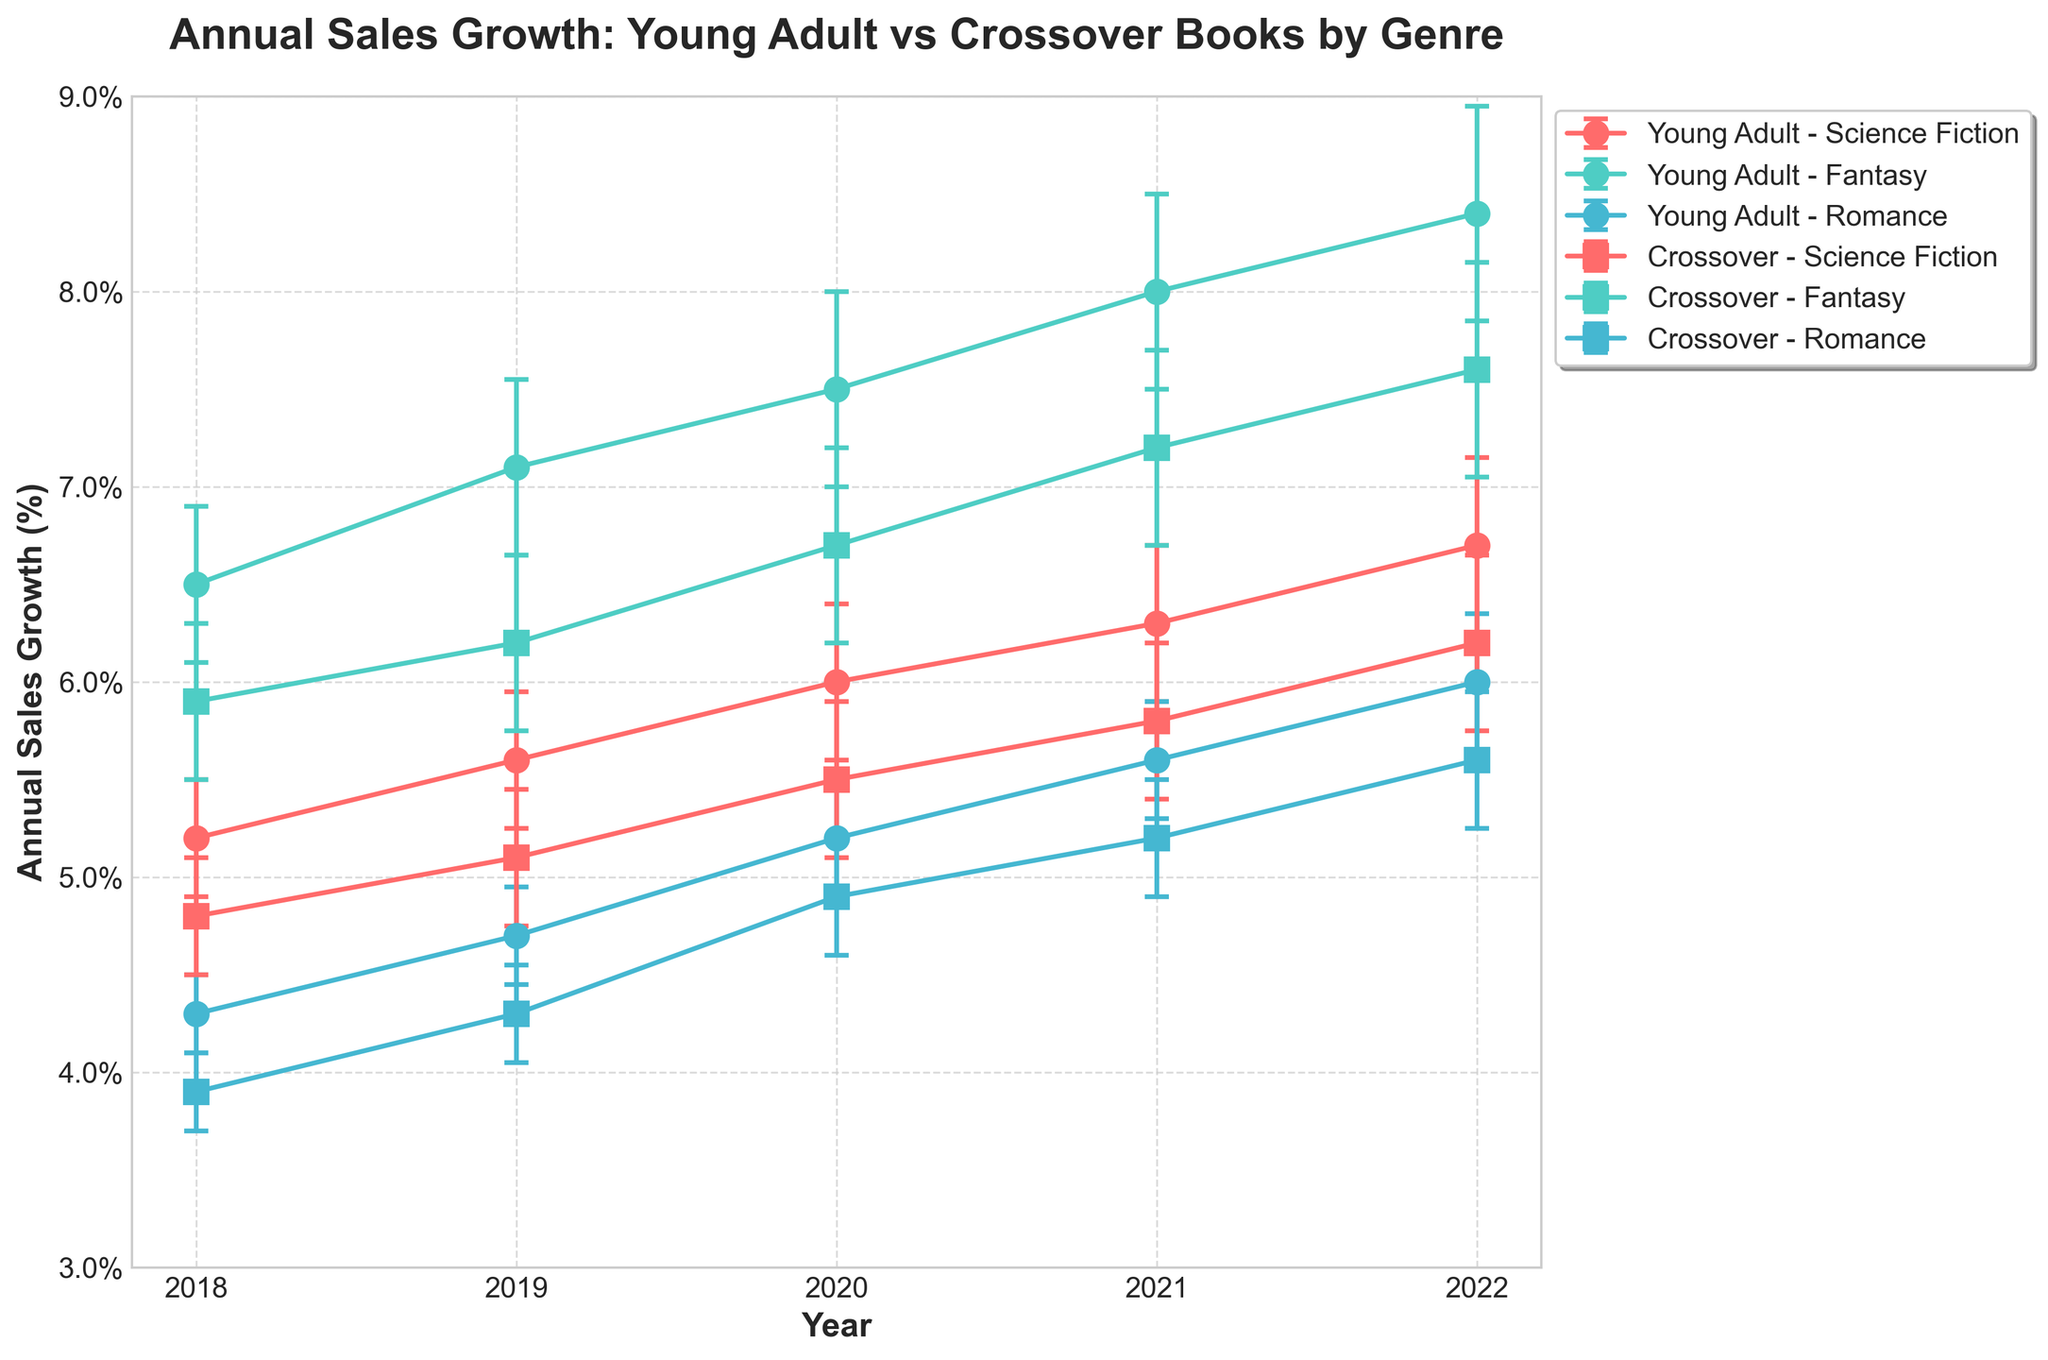What is the title of the figure? The main heading at the top of the figure describes its overall subject.
Answer: Annual Sales Growth: Young Adult vs Crossover Books by Genre How is the sales growth trend for Young Adult Fantasy books over the years? The line representing Young Adult Fantasy books starts around 6.5% in 2018 and gradually increases each year, reaching 8.4% in 2022.
Answer: Increasing Which category and genre combination had the highest annual sales growth in 2022? By observing the highest point on the graph for the year 2022, the Young Adult category with the Fantasy genre shows the highest value at 8.4%.
Answer: Young Adult Fantasy How do the error bars for Young Adult Science Fiction books in 2018 compare to 2022? In 2018, the error bar has a smaller error value (0.3) compared to a larger error bar value (0.45) in 2022, indicating increased uncertainty.
Answer: Increased What is the average annual sales growth for Crossover Romance books from 2018 to 2022? Sum the annual values for each year (3.9+4.3+4.9+5.2+5.6) and divide by the number of years (5). The average is approximately (24.9 / 5) = 4.98%.
Answer: 4.98% Which genre shows the most consistent growth rate between Young Adult and Crossover categories? Consistency can be evaluated by the smoothness and minimal change of the growth rate line over time. Young Adult Romance appears more consistent, despite its lower growth rates, than other genres showing fluctuations.
Answer: Young Adult Romance What year did the crossover category surpass Young Adult in Science Fiction sales growth? By comparing the crossover and Young Adult lines for Science Fiction, we see that the crossover line surpasses the Young Adult in 2022.
Answer: 2022 Is the sales growth for Crossover Fantasy books higher than that of Young Adult Romance books in 2021? By checking the points in the graph for the respective year, 2021, Crossover Fantasy stands at approximately 7.2%, while Young Adult Romance stands at around 5.6%.
Answer: Yes Which year saw the largest increase in growth rate for Young Adult Sci-Fi books? By observing the steepest upward trend in the Young Adult Science Fiction line, the largest increase is from 2021 to 2022 (from 6.3% to 6.7%).
Answer: 2021-2022 What is the overall trend of Crossover Romance book sales growth from 2018 to 2022? The Crossover Romance line shows a gradual upward trend from 3.9% in 2018 to 5.6% in 2022, indicating a steady increase each year.
Answer: Increasing 